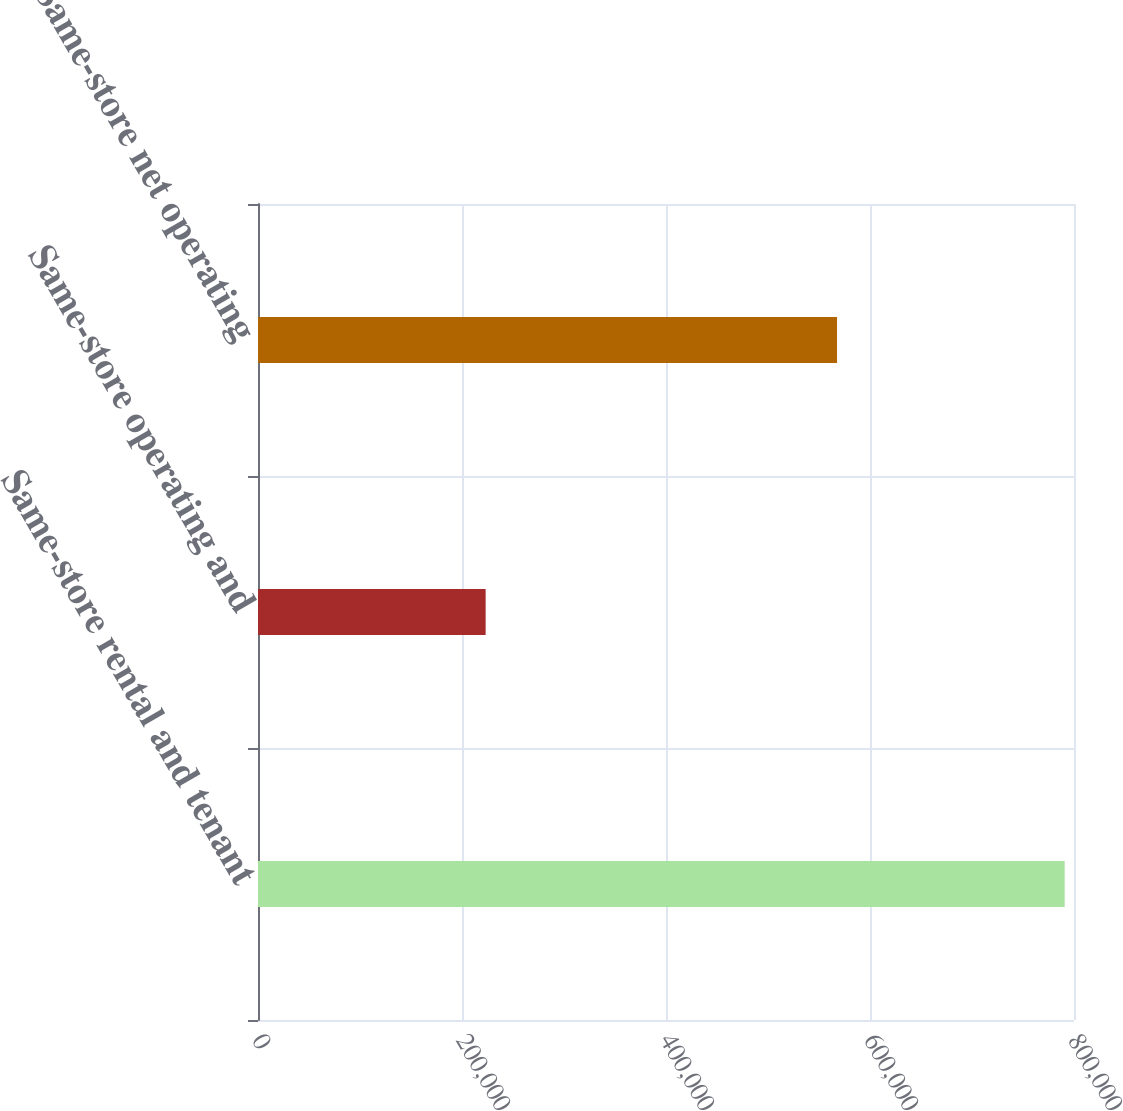Convert chart to OTSL. <chart><loc_0><loc_0><loc_500><loc_500><bar_chart><fcel>Same-store rental and tenant<fcel>Same-store operating and<fcel>Same-store net operating<nl><fcel>790864<fcel>223173<fcel>567691<nl></chart> 